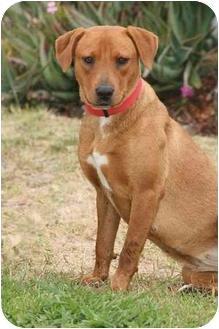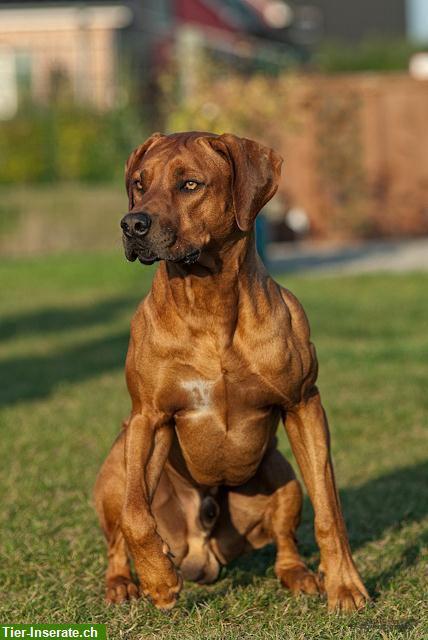The first image is the image on the left, the second image is the image on the right. Given the left and right images, does the statement "The right image contains exactly two dogs." hold true? Answer yes or no. No. The first image is the image on the left, the second image is the image on the right. Given the left and right images, does the statement "One image includes a sitting dog wearing a collar, and the other image features a dog with one raised front paw." hold true? Answer yes or no. Yes. 